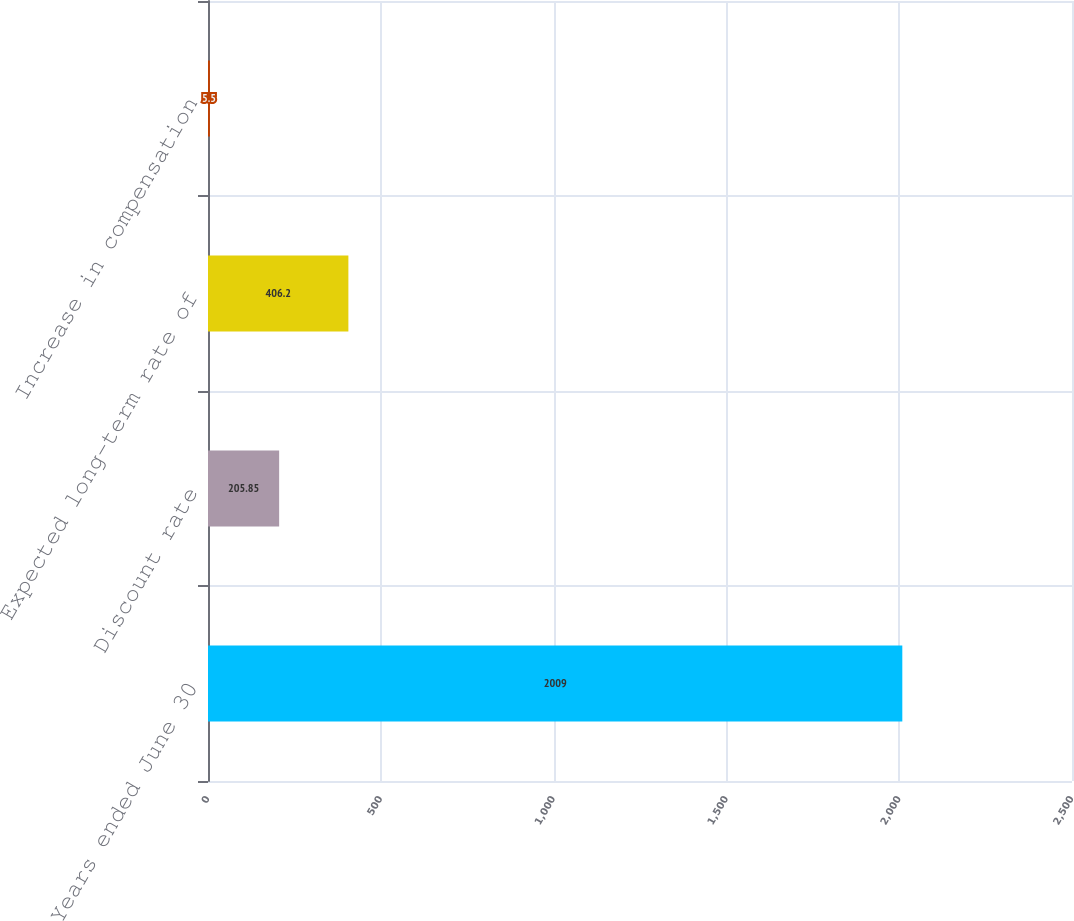Convert chart. <chart><loc_0><loc_0><loc_500><loc_500><bar_chart><fcel>Years ended June 30<fcel>Discount rate<fcel>Expected long-term rate of<fcel>Increase in compensation<nl><fcel>2009<fcel>205.85<fcel>406.2<fcel>5.5<nl></chart> 